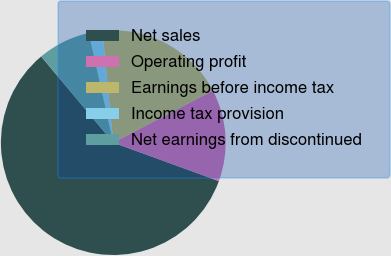Convert chart to OTSL. <chart><loc_0><loc_0><loc_500><loc_500><pie_chart><fcel>Net sales<fcel>Operating profit<fcel>Earnings before income tax<fcel>Income tax provision<fcel>Net earnings from discontinued<nl><fcel>58.35%<fcel>13.23%<fcel>18.87%<fcel>1.95%<fcel>7.59%<nl></chart> 